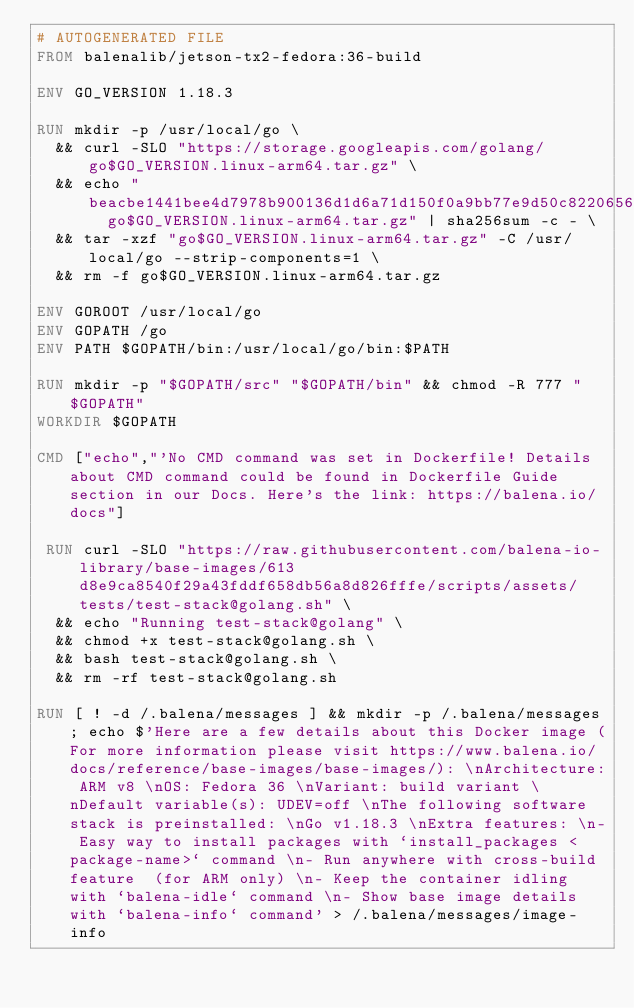Convert code to text. <code><loc_0><loc_0><loc_500><loc_500><_Dockerfile_># AUTOGENERATED FILE
FROM balenalib/jetson-tx2-fedora:36-build

ENV GO_VERSION 1.18.3

RUN mkdir -p /usr/local/go \
	&& curl -SLO "https://storage.googleapis.com/golang/go$GO_VERSION.linux-arm64.tar.gz" \
	&& echo "beacbe1441bee4d7978b900136d1d6a71d150f0a9bb77e9d50c822065623a35a  go$GO_VERSION.linux-arm64.tar.gz" | sha256sum -c - \
	&& tar -xzf "go$GO_VERSION.linux-arm64.tar.gz" -C /usr/local/go --strip-components=1 \
	&& rm -f go$GO_VERSION.linux-arm64.tar.gz

ENV GOROOT /usr/local/go
ENV GOPATH /go
ENV PATH $GOPATH/bin:/usr/local/go/bin:$PATH

RUN mkdir -p "$GOPATH/src" "$GOPATH/bin" && chmod -R 777 "$GOPATH"
WORKDIR $GOPATH

CMD ["echo","'No CMD command was set in Dockerfile! Details about CMD command could be found in Dockerfile Guide section in our Docs. Here's the link: https://balena.io/docs"]

 RUN curl -SLO "https://raw.githubusercontent.com/balena-io-library/base-images/613d8e9ca8540f29a43fddf658db56a8d826fffe/scripts/assets/tests/test-stack@golang.sh" \
  && echo "Running test-stack@golang" \
  && chmod +x test-stack@golang.sh \
  && bash test-stack@golang.sh \
  && rm -rf test-stack@golang.sh 

RUN [ ! -d /.balena/messages ] && mkdir -p /.balena/messages; echo $'Here are a few details about this Docker image (For more information please visit https://www.balena.io/docs/reference/base-images/base-images/): \nArchitecture: ARM v8 \nOS: Fedora 36 \nVariant: build variant \nDefault variable(s): UDEV=off \nThe following software stack is preinstalled: \nGo v1.18.3 \nExtra features: \n- Easy way to install packages with `install_packages <package-name>` command \n- Run anywhere with cross-build feature  (for ARM only) \n- Keep the container idling with `balena-idle` command \n- Show base image details with `balena-info` command' > /.balena/messages/image-info</code> 